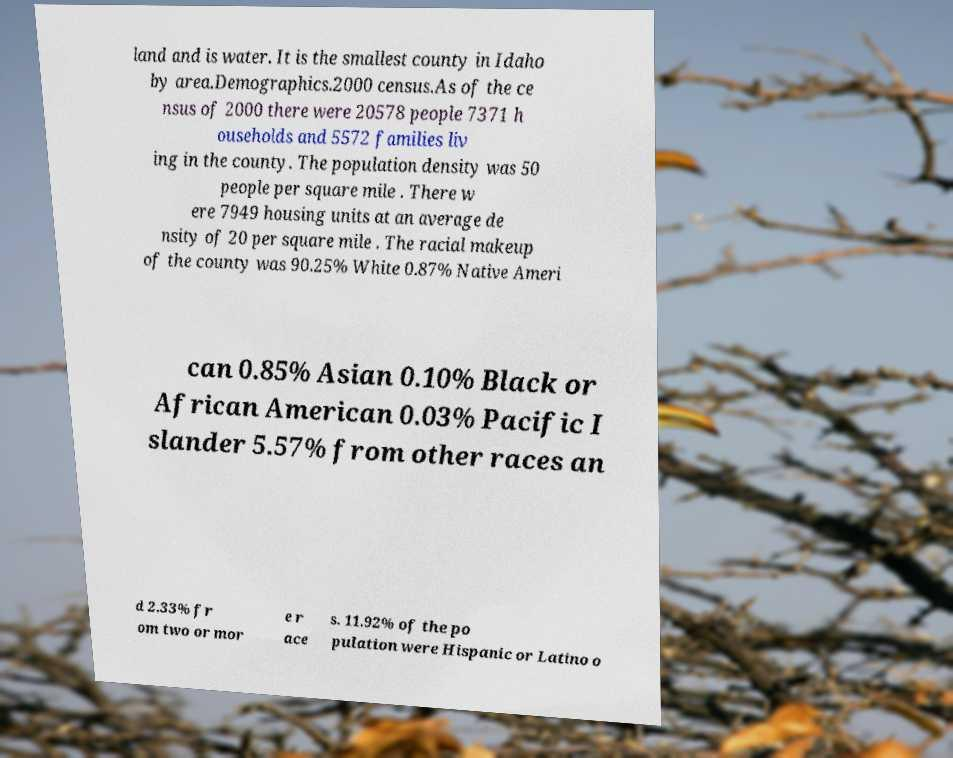What messages or text are displayed in this image? I need them in a readable, typed format. land and is water. It is the smallest county in Idaho by area.Demographics.2000 census.As of the ce nsus of 2000 there were 20578 people 7371 h ouseholds and 5572 families liv ing in the county. The population density was 50 people per square mile . There w ere 7949 housing units at an average de nsity of 20 per square mile . The racial makeup of the county was 90.25% White 0.87% Native Ameri can 0.85% Asian 0.10% Black or African American 0.03% Pacific I slander 5.57% from other races an d 2.33% fr om two or mor e r ace s. 11.92% of the po pulation were Hispanic or Latino o 